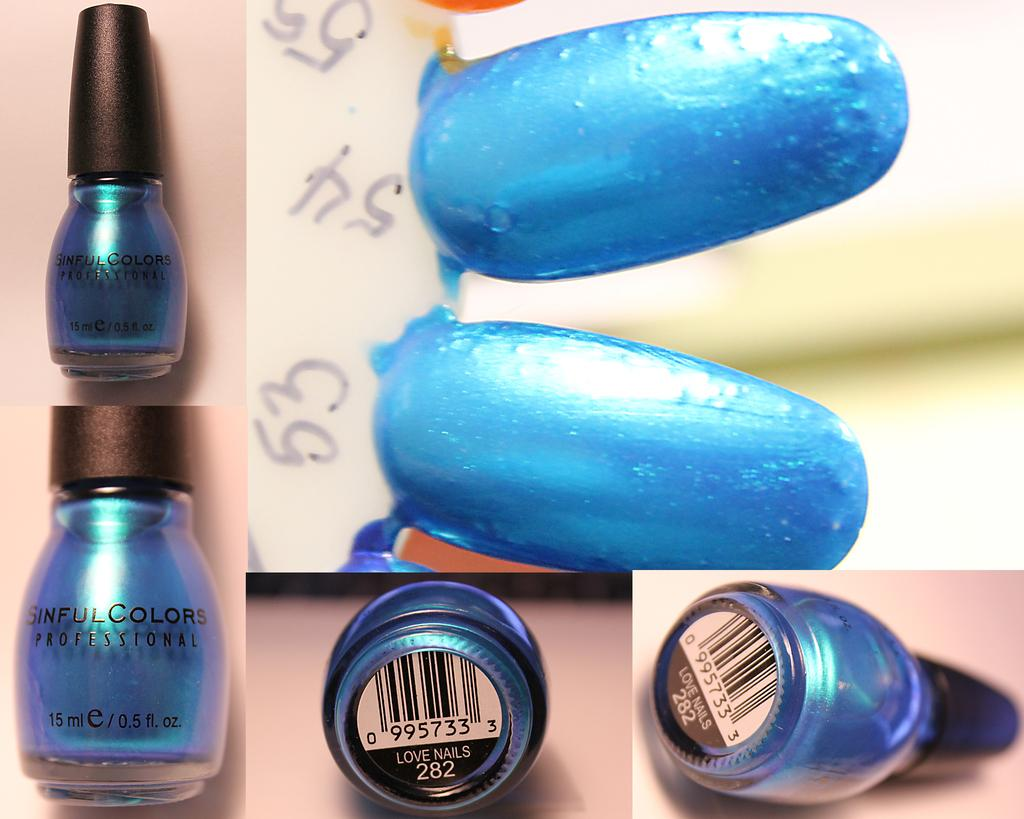<image>
Present a compact description of the photo's key features. The blue nail polish is color number 282. 